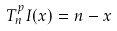<formula> <loc_0><loc_0><loc_500><loc_500>T _ { n } ^ { p } I ( x ) = n - x</formula> 